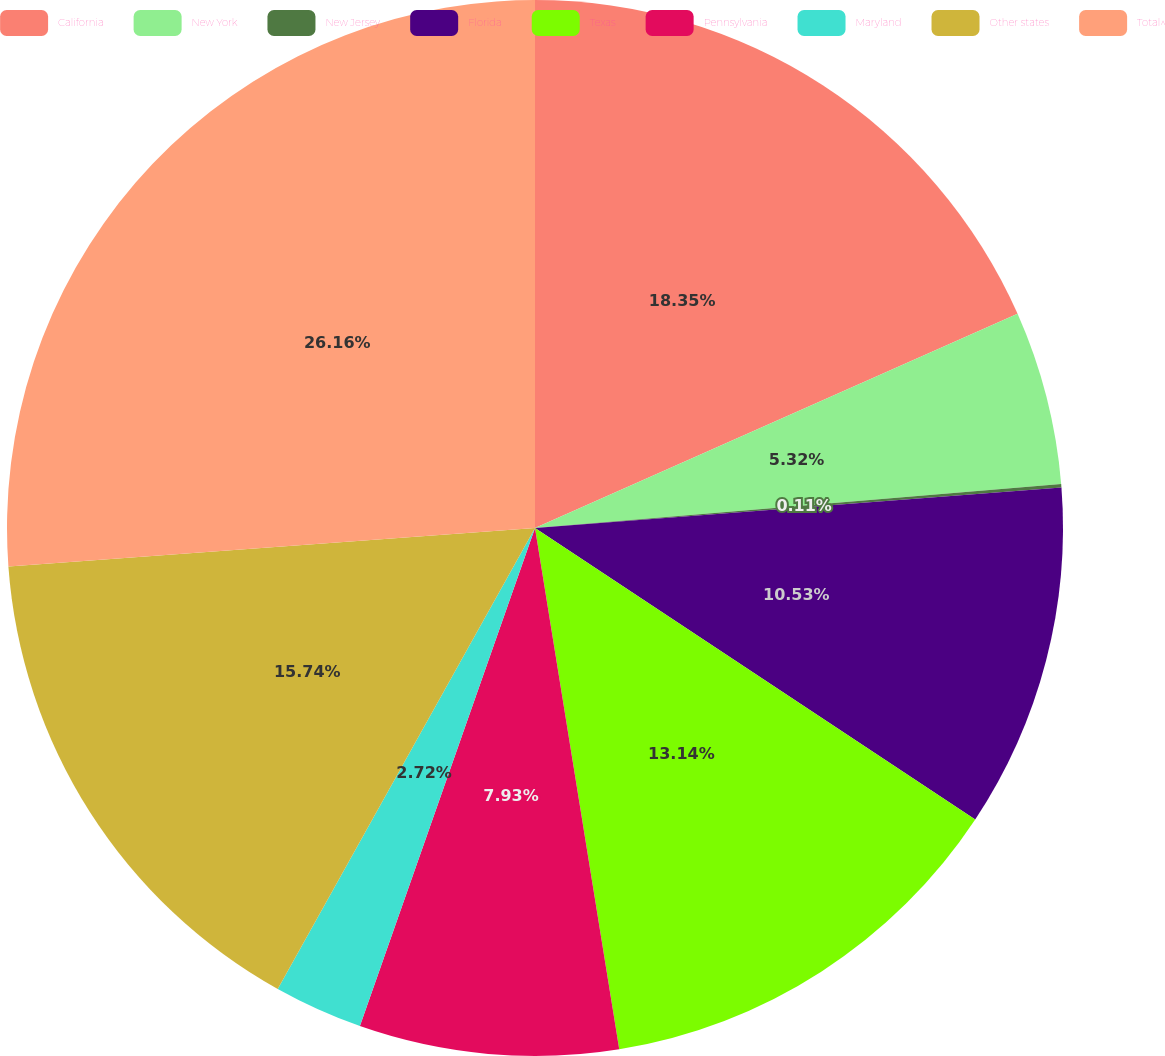Convert chart. <chart><loc_0><loc_0><loc_500><loc_500><pie_chart><fcel>California<fcel>New York<fcel>New Jersey<fcel>Florida<fcel>Texas<fcel>Pennsylvania<fcel>Maryland<fcel>Other states<fcel>Total^<nl><fcel>18.35%<fcel>5.32%<fcel>0.11%<fcel>10.53%<fcel>13.14%<fcel>7.93%<fcel>2.72%<fcel>15.74%<fcel>26.16%<nl></chart> 